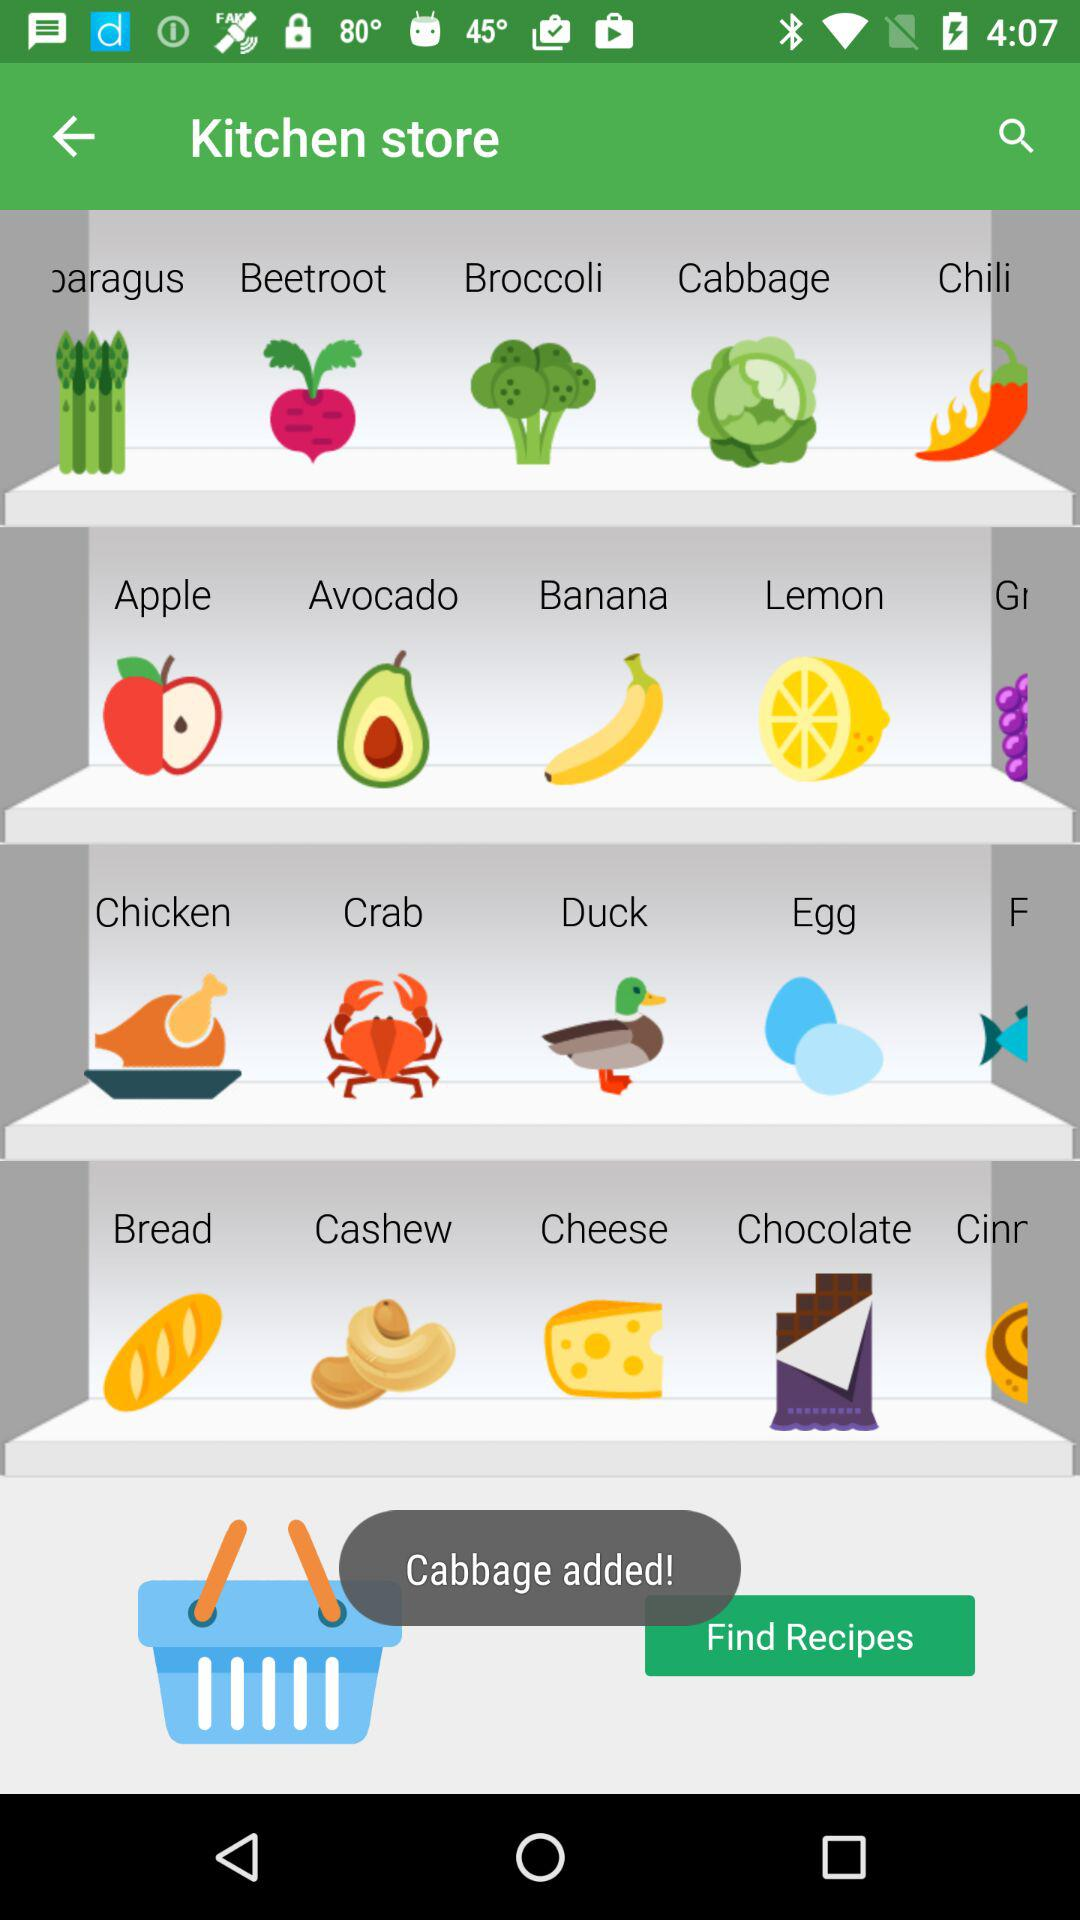What item has been added? The item that has been added is cabbage. 